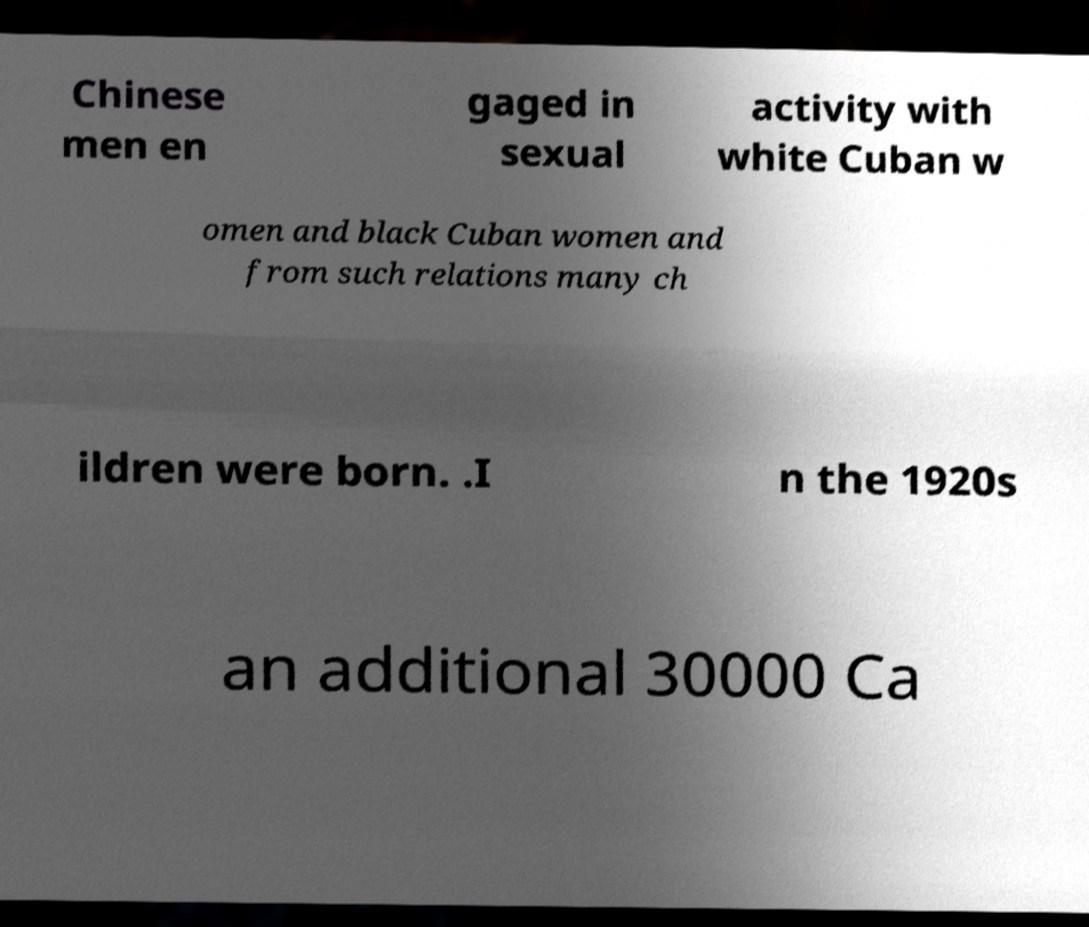There's text embedded in this image that I need extracted. Can you transcribe it verbatim? Chinese men en gaged in sexual activity with white Cuban w omen and black Cuban women and from such relations many ch ildren were born. .I n the 1920s an additional 30000 Ca 